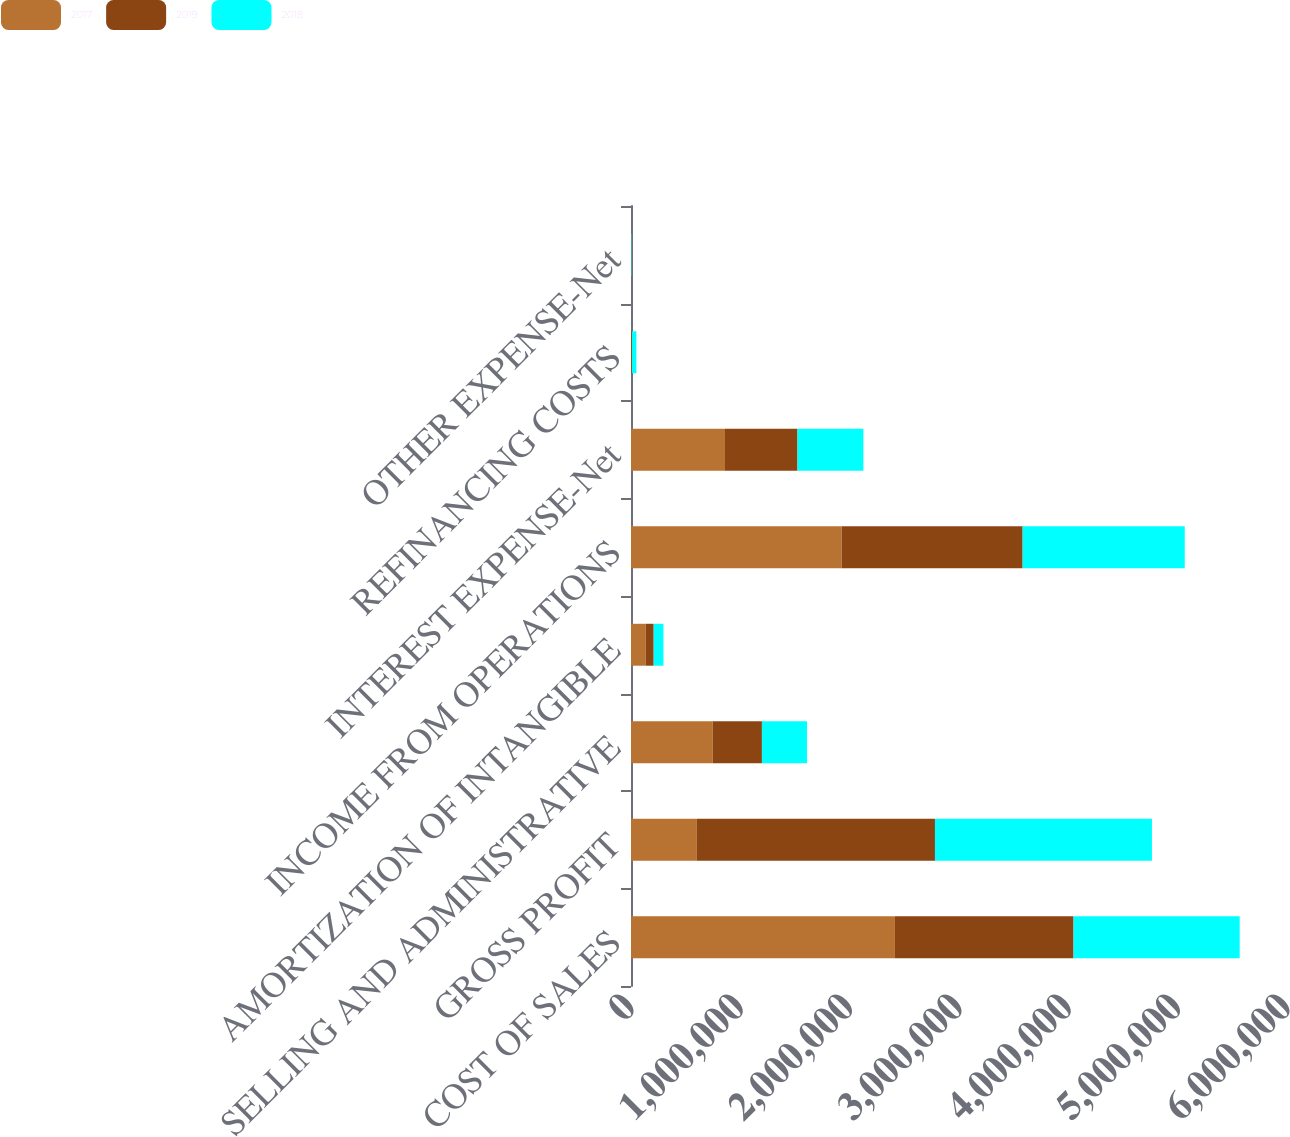<chart> <loc_0><loc_0><loc_500><loc_500><stacked_bar_chart><ecel><fcel>COST OF SALES<fcel>GROSS PROFIT<fcel>SELLING AND ADMINISTRATIVE<fcel>AMORTIZATION OF INTANGIBLE<fcel>INCOME FROM OPERATIONS<fcel>INTEREST EXPENSE-Net<fcel>REFINANCING COSTS<fcel>OTHER EXPENSE-Net<nl><fcel>2017<fcel>2.41393e+06<fcel>602589<fcel>747773<fcel>134952<fcel>1.92655e+06<fcel>859753<fcel>3013<fcel>915<nl><fcel>2019<fcel>1.63362e+06<fcel>2.17751e+06<fcel>449676<fcel>72454<fcel>1.65538e+06<fcel>663008<fcel>6396<fcel>419<nl><fcel>2018<fcel>1.51966e+06<fcel>1.98463e+06<fcel>412555<fcel>89226<fcel>1.48285e+06<fcel>602589<fcel>39807<fcel>3020<nl></chart> 